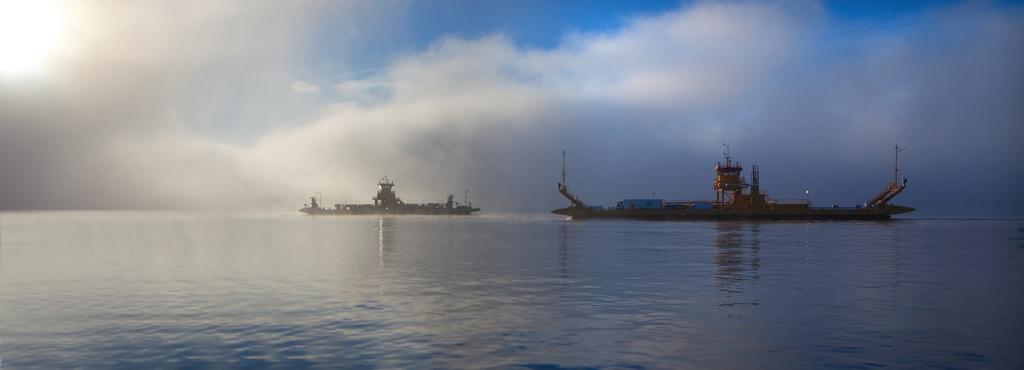How would you summarize this image in a sentence or two? In this image I can see two ships on the water. In the background the sky is in blue and white color. 